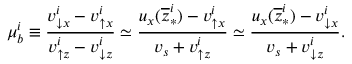Convert formula to latex. <formula><loc_0><loc_0><loc_500><loc_500>\mu _ { b } ^ { i } \equiv \frac { v _ { \downarrow x } ^ { i } - v _ { \uparrow x } ^ { i } } { v _ { \uparrow z } ^ { i } - v _ { \downarrow z } ^ { i } } \simeq \frac { u _ { x } ( \overline { z } _ { \ast } ^ { i } ) - v _ { \uparrow x } ^ { i } } { v _ { s } + v _ { \uparrow z } ^ { i } } \simeq \frac { u _ { x } ( \overline { z } _ { \ast } ^ { i } ) - v _ { \downarrow x } ^ { i } } { v _ { s } + v _ { \downarrow z } ^ { i } } .</formula> 